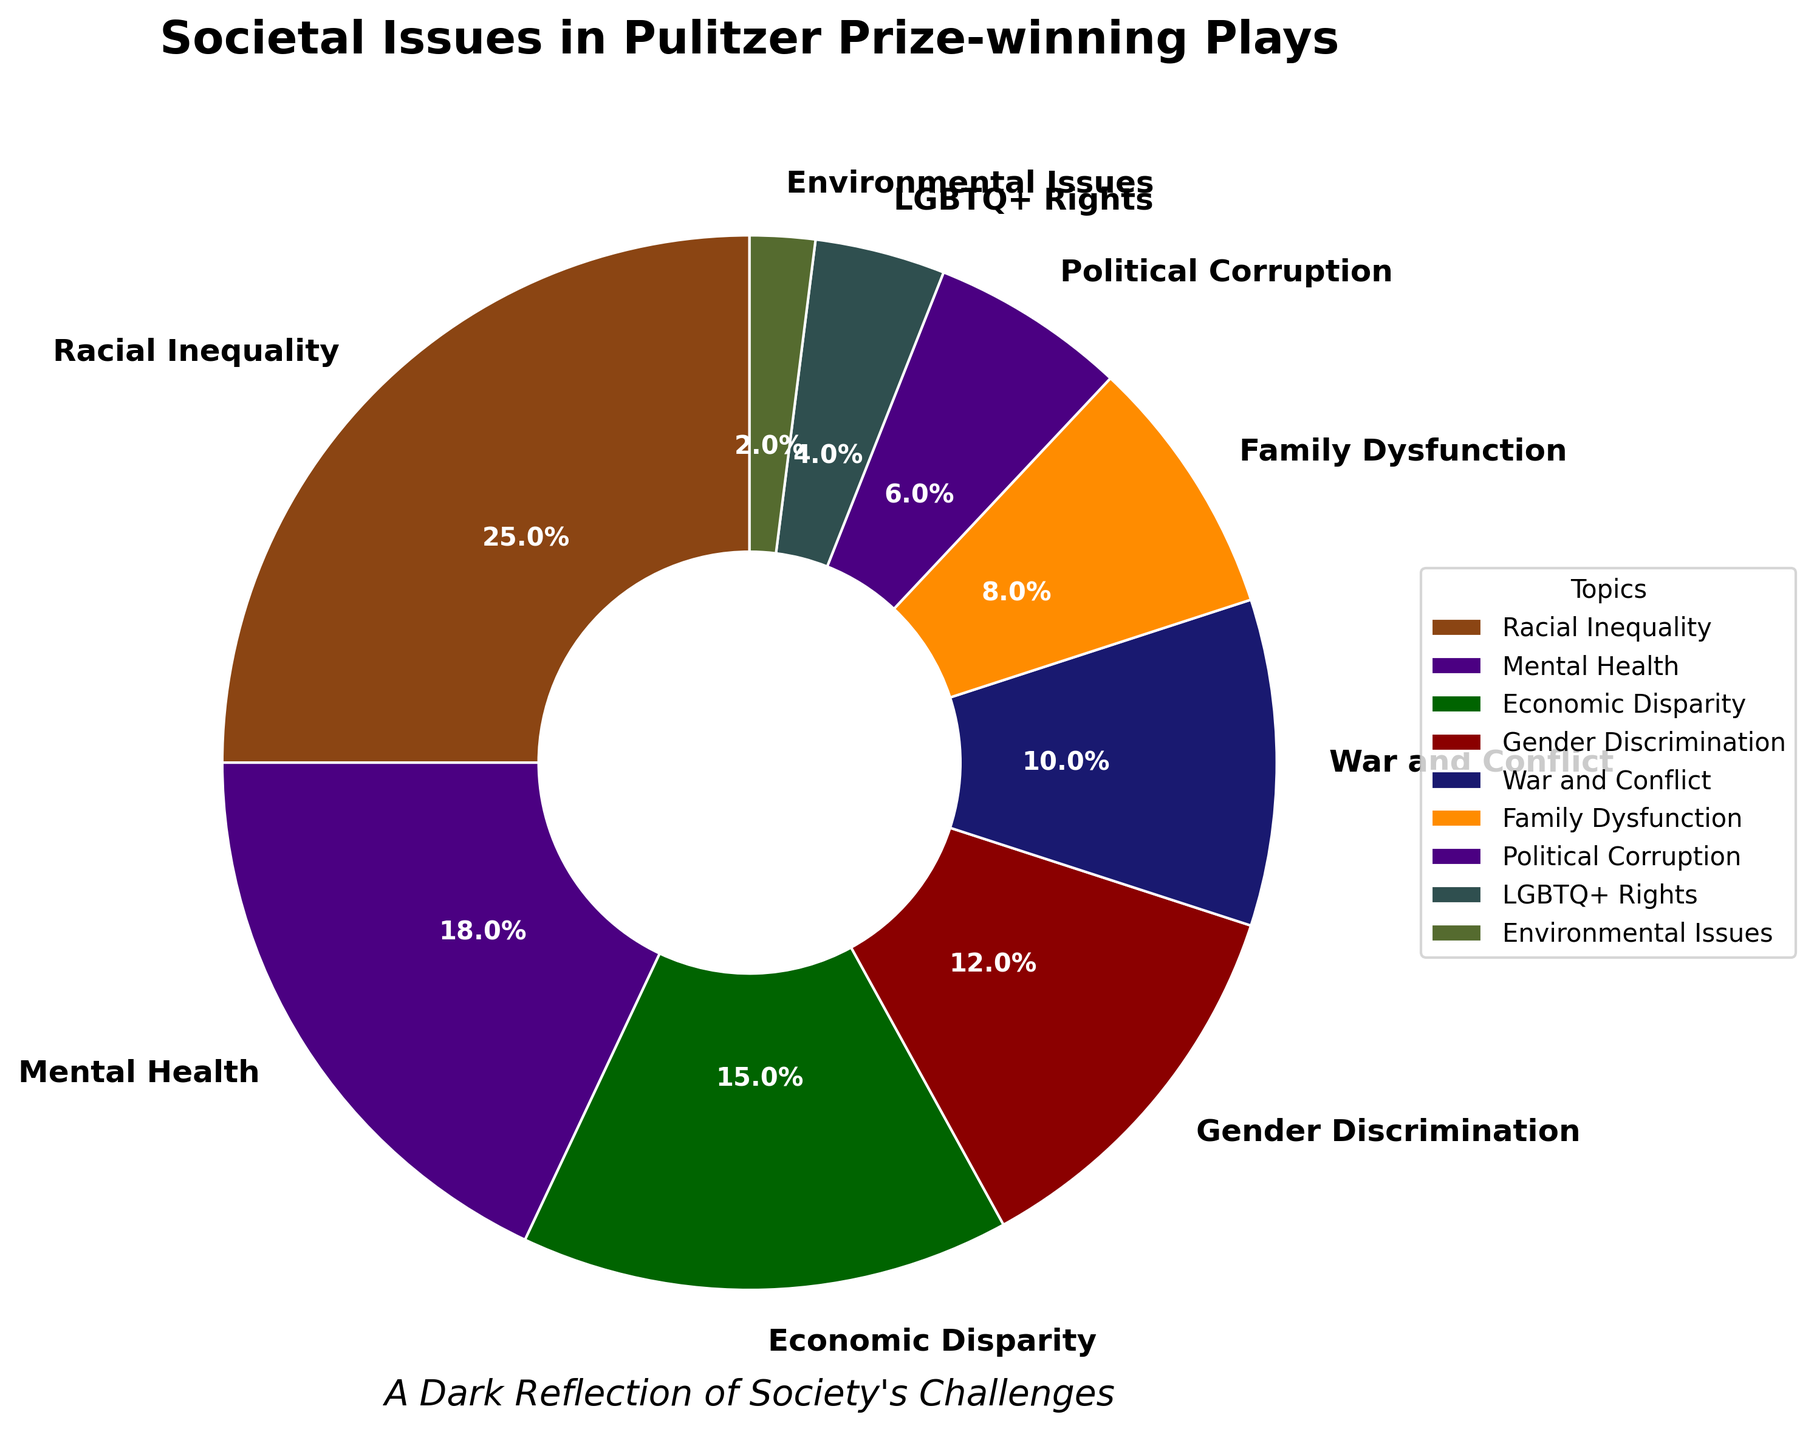Which societal issue is most frequently addressed in Pulitzer Prize-winning plays? From the pie chart, "Racial Inequality" occupies the largest segment, indicating it is the most frequently addressed issue with a percentage of 25.
Answer: Racial Inequality What percentage of Pulitzer Prize-winning plays address issues related to Gender Discrimination and LGBTQ+ Rights combined? The percentages for Gender Discrimination and LGBTQ+ Rights are 12% and 4%, respectively. Summing these up gives 12 + 4 = 16.
Answer: 16% Between Economic Disparity and Family Dysfunction, which issue is addressed more frequently? By inspecting the pie chart, "Economic Disparity" has a segment labeled 15%, whereas "Family Dysfunction" has a segment labeled 8%. Hence, Economic Disparity is more frequently addressed.
Answer: Economic Disparity Which issue is represented by the smallest segment in the pie chart? Observing the pie chart, the smallest segment is labeled "Environmental Issues" with a percentage of 2, making it the least frequently addressed issue.
Answer: Environmental Issues What is the total percentage of Pulitzer Prize-winning plays that address either War and Conflict or Political Corruption? Summing the percentages given for War and Conflict (10%) and Political Corruption (6%) results in a total of 10 + 6 = 16.
Answer: 16% Compare the percentages of plays addressing Mental Health and Economic Disparity. Which is higher and by how much? By examining the pie chart, "Mental Health" has a percentage of 18, while "Economic Disparity" has 15. The difference is 18 - 15 = 3. Hence, Mental Health is 3% higher.
Answer: Mental Health by 3% What is the cumulative percentage of plays that address Racial Inequality, Mental Health, and Economic Disparity? The percentages for these issues are 25%, 18%, and 15%, respectively. Summing them gives 25 + 18 + 15 = 58.
Answer: 58% Which color in the pie chart represents the segment for Family Dysfunction? Looking at the color differentiation in the pie chart, Family Dysfunction is represented by a segment colored in orange.
Answer: Orange Out of the segments for LGBTQ+ Rights and Environmental Issues, which one occupies a larger portion of the pie chart? Observing the pie chart, the segment for LGBTQ+ Rights is 4% whereas Environmental Issues is 2%. Hence, LGBTQ+ Rights occupies a larger portion.
Answer: LGBTQ+ Rights 